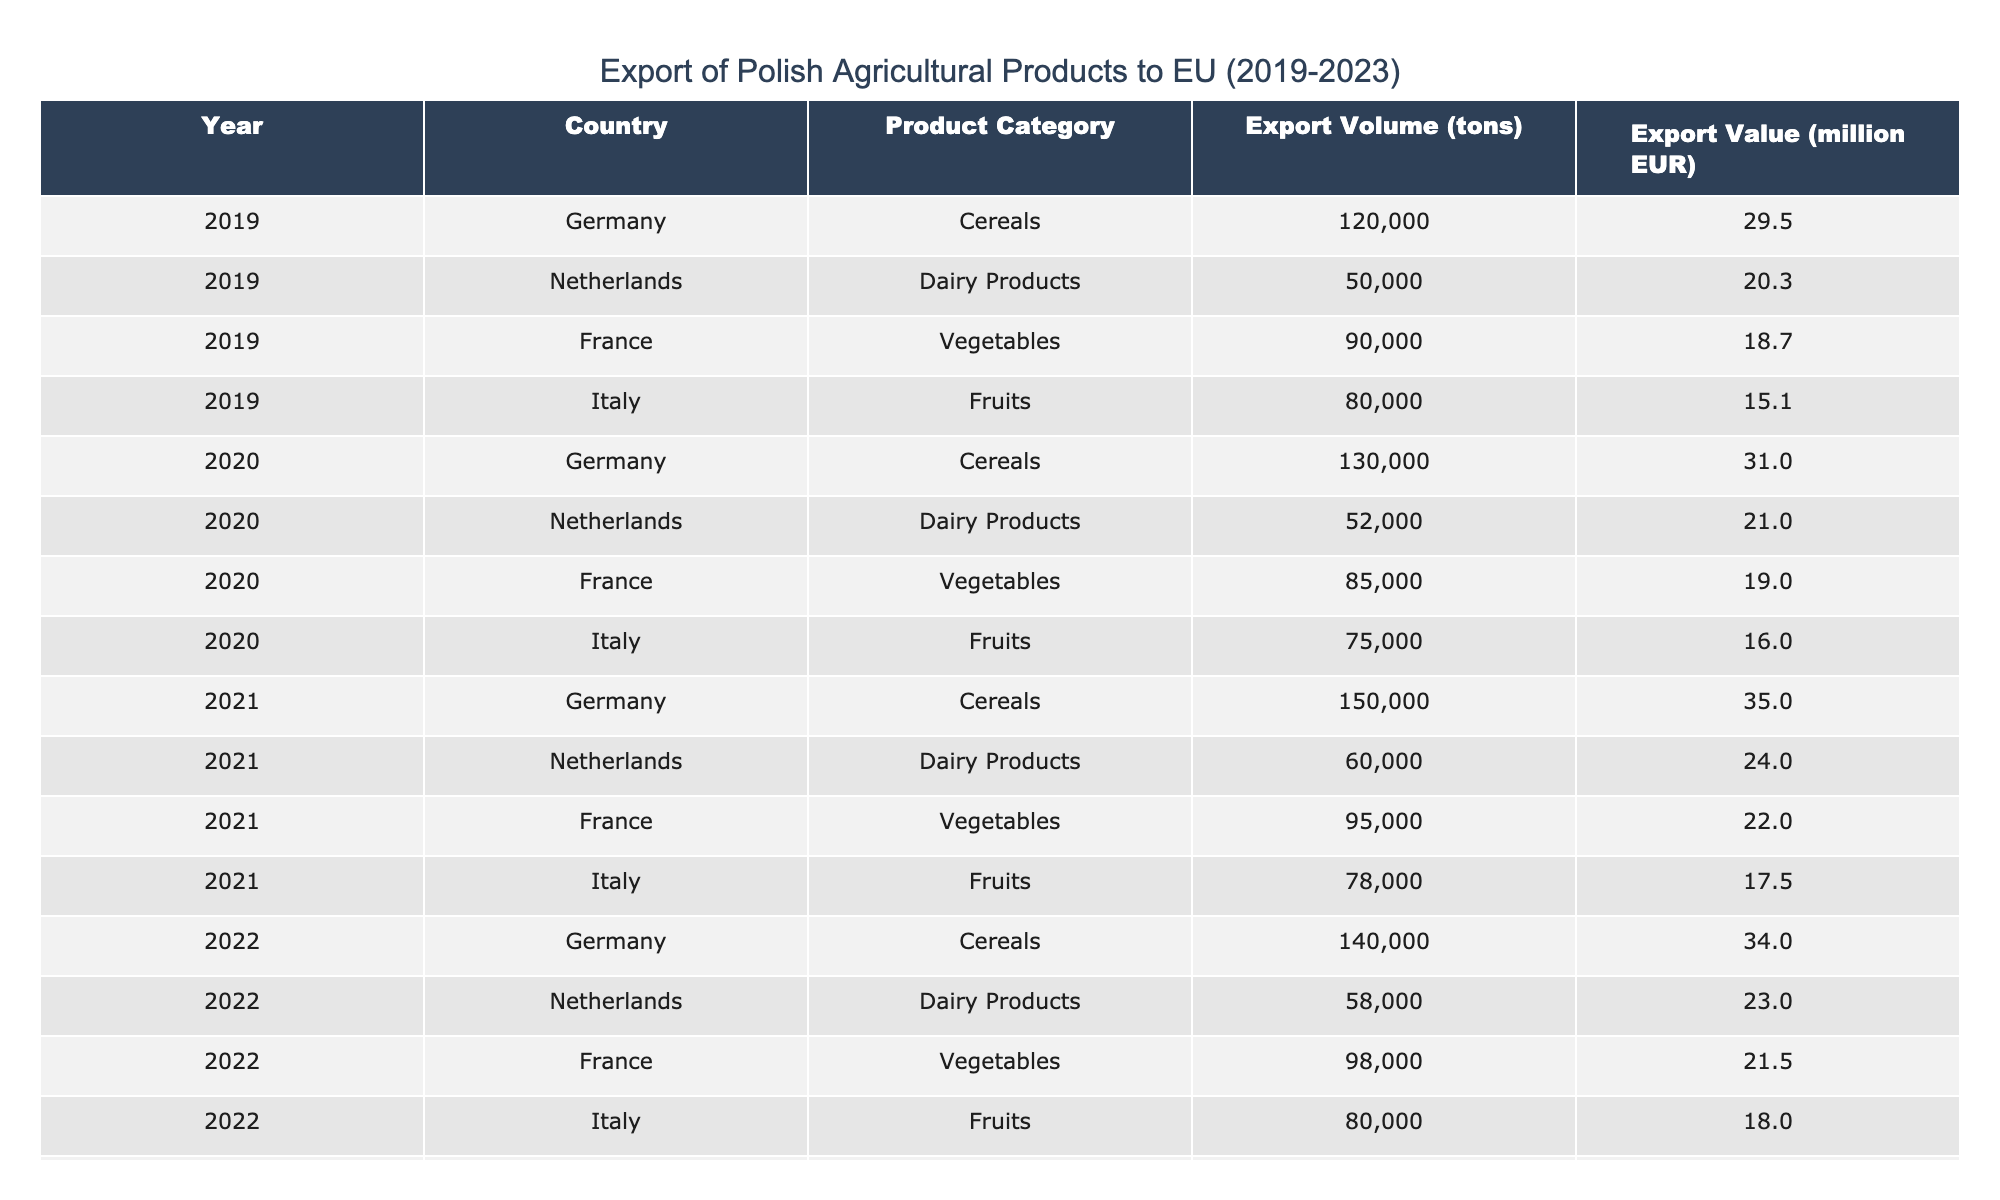What was the export volume of Polish cereals to Germany in 2021? The table lists the export volume of Polish cereals to Germany in 2021 as 150,000 tons.
Answer: 150000 tons Which country received the highest export value of Polish dairy products in 2023? According to the table, the Netherlands had the highest export value of Polish dairy products in 2023 at 26 million EUR.
Answer: 26 million EUR What is the total export volume of fruits to Italy from 2019 to 2023? To find the total export volume of fruits to Italy, we add the export volumes for each year: 80,000 (2019) + 75,000 (2020) + 78,000 (2021) + 80,000 (2022) + 82,000 (2023) = 395,000 tons.
Answer: 395000 tons Did the export volume of Polish vegetables to France increase every year from 2019 to 2023? By reviewing the table, we see that the export volumes of Polish vegetables to France were 90,000 (2019), 85,000 (2020), 95,000 (2021), 98,000 (2022), and 100,000 (2023). Since it did not increase in 2020, the answer is no.
Answer: No What was the average export value of Polish fruits from 2019 to 2023? The average export value can be calculated by summing the values for each year: 15.1 (2019) + 16.0 (2020) + 17.5 (2021) + 18.0 (2022) + 19.2 (2023) = 85.8 million EUR. Then, divide by 5 years: 85.8 / 5 = 17.16 million EUR.
Answer: 17.16 million EUR What was the trend in the export volumes of Polish cereals from 2019 to 2023? Analyzing the data, the export volumes of Polish cereals were: 120,000 (2019), 130,000 (2020), 150,000 (2021), 140,000 (2022), and 160,000 (2023). The overall trend shows an increase from 2019 to 2021, a slight decrease in 2022, and an increase again in 2023.
Answer: Increasing with a slight decrease in 2022 Which product category had the lowest export volume in 2020? The table indicates that in 2020, the export volume for dairy products to the Netherlands was 52,000 tons, which is the lowest compared to other product categories that year.
Answer: Dairy Products to Netherlands: 52000 tons In which year did Polish vegetables have the highest export value? Looking at the table, the export value for Polish vegetables to France was highest in 2021 at 22 million EUR.
Answer: 2021 